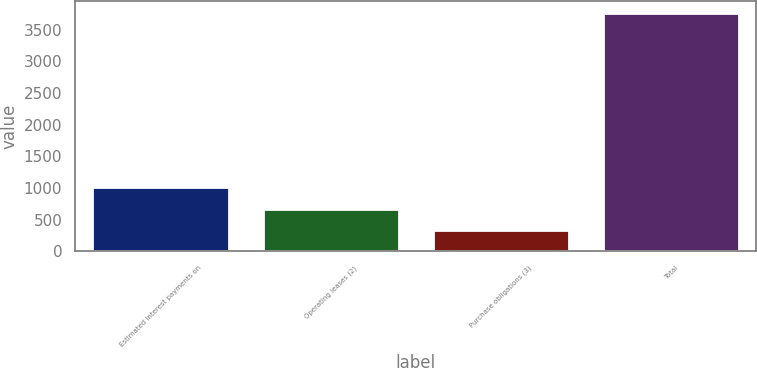<chart> <loc_0><loc_0><loc_500><loc_500><bar_chart><fcel>Estimated interest payments on<fcel>Operating leases (2)<fcel>Purchase obligations (3)<fcel>Total<nl><fcel>1020.32<fcel>677.06<fcel>333.8<fcel>3766.4<nl></chart> 